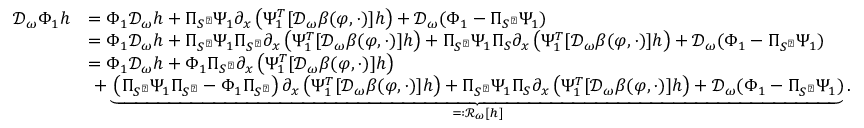Convert formula to latex. <formula><loc_0><loc_0><loc_500><loc_500>\begin{array} { r l } { \mathcal { D } _ { \omega } \Phi _ { 1 } h } & { = \Phi _ { 1 } \mathcal { D } _ { \omega } h + \Pi _ { S ^ { \perp } } \Psi _ { 1 } \partial _ { x } \left ( \Psi _ { 1 } ^ { T } [ \mathcal { D } _ { \omega } \beta ( \varphi , \cdot ) ] h \right ) + \mathcal { D } _ { \omega } ( \Phi _ { 1 } - \Pi _ { S ^ { \perp } } \Psi _ { 1 } ) } \\ & { = \Phi _ { 1 } \mathcal { D } _ { \omega } h + \Pi _ { S ^ { \perp } } \Psi _ { 1 } \Pi _ { S ^ { \perp } } \partial _ { x } \left ( \Psi _ { 1 } ^ { T } [ \mathcal { D } _ { \omega } \beta ( \varphi , \cdot ) ] h \right ) + \Pi _ { S ^ { \perp } } \Psi _ { 1 } \Pi _ { S } \partial _ { x } \left ( \Psi _ { 1 } ^ { T } [ \mathcal { D } _ { \omega } \beta ( \varphi , \cdot ) ] h \right ) + \mathcal { D } _ { \omega } ( \Phi _ { 1 } - \Pi _ { S ^ { \perp } } \Psi _ { 1 } ) } \\ & { = \Phi _ { 1 } \mathcal { D } _ { \omega } h + \Phi _ { 1 } \Pi _ { S ^ { \perp } } \partial _ { x } \left ( \Psi _ { 1 } ^ { T } [ \mathcal { D } _ { \omega } \beta ( \varphi , \cdot ) ] h \right ) } \\ & { \ + \underbrace { \left ( \Pi _ { S ^ { \perp } } \Psi _ { 1 } \Pi _ { S ^ { \perp } } - \Phi _ { 1 } \Pi _ { S ^ { \perp } } \right ) \partial _ { x } \left ( \Psi _ { 1 } ^ { T } [ \mathcal { D } _ { \omega } \beta ( \varphi , \cdot ) ] h \right ) + \Pi _ { S ^ { \perp } } \Psi _ { 1 } \Pi _ { S } \partial _ { x } \left ( \Psi _ { 1 } ^ { T } [ \mathcal { D } _ { \omega } \beta ( \varphi , \cdot ) ] h \right ) + \mathcal { D } _ { \omega } ( \Phi _ { 1 } - \Pi _ { S ^ { \perp } } \Psi _ { 1 } ) } _ { = \colon \mathcal { R } _ { \omega } [ h ] } . } \end{array}</formula> 